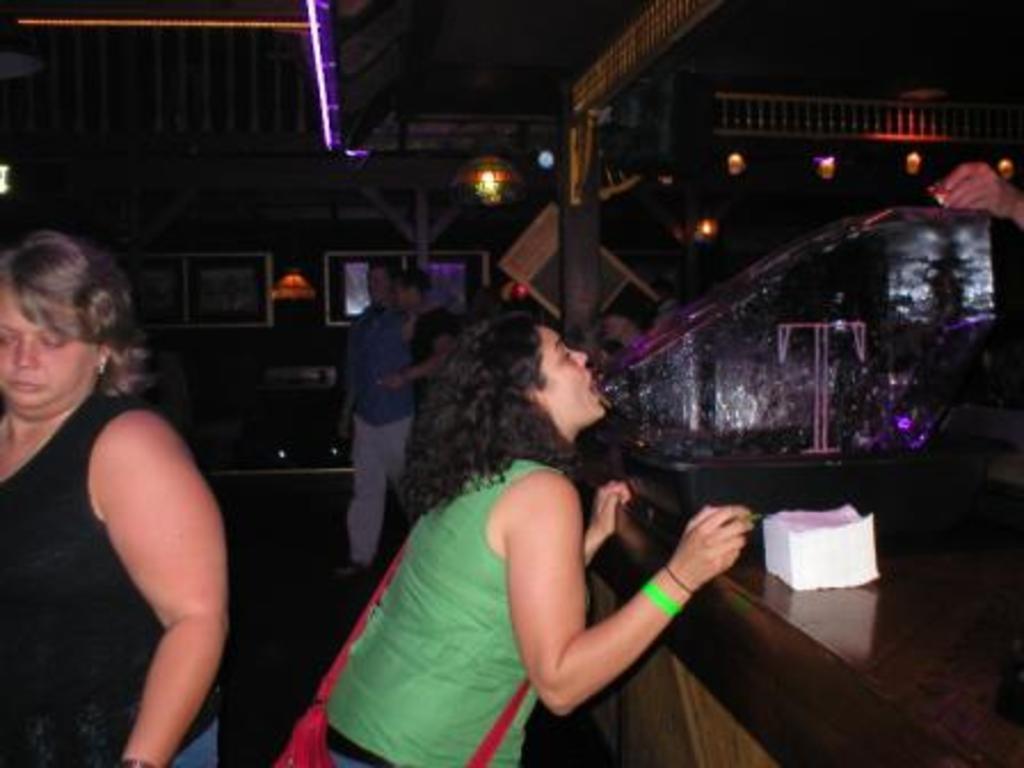Describe this image in one or two sentences. There is one woman standing at the bottom of this image, and there is another woman wearing black color t shirt on the left side of this image. There are two men and a wall in the background. There is a tissue bundle kept on a table on the right side of this image. We can see some lights at the top of this image. 